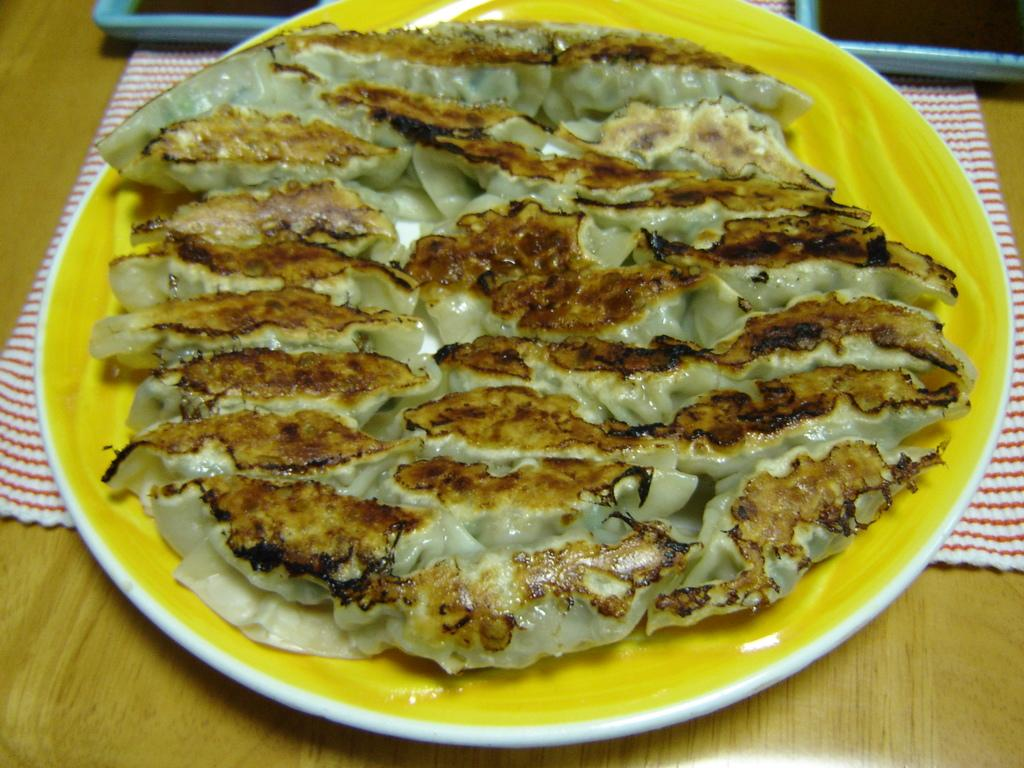What is on the plate that is visible in the image? There is a food item on a plate in the image. Where is the plate with the food item located? The plate is on top of a table. What is beneath the plate with the food item? There is a napkin beneath the plate. How many other plates are there beside the plate with the food item? There are two other plates beside the plate with the food item. What type of brick is used to build the oven for the pizzas in the image? There are no pizzas or ovens present in the image; it only features a plate with a food item, a table, and a napkin. 